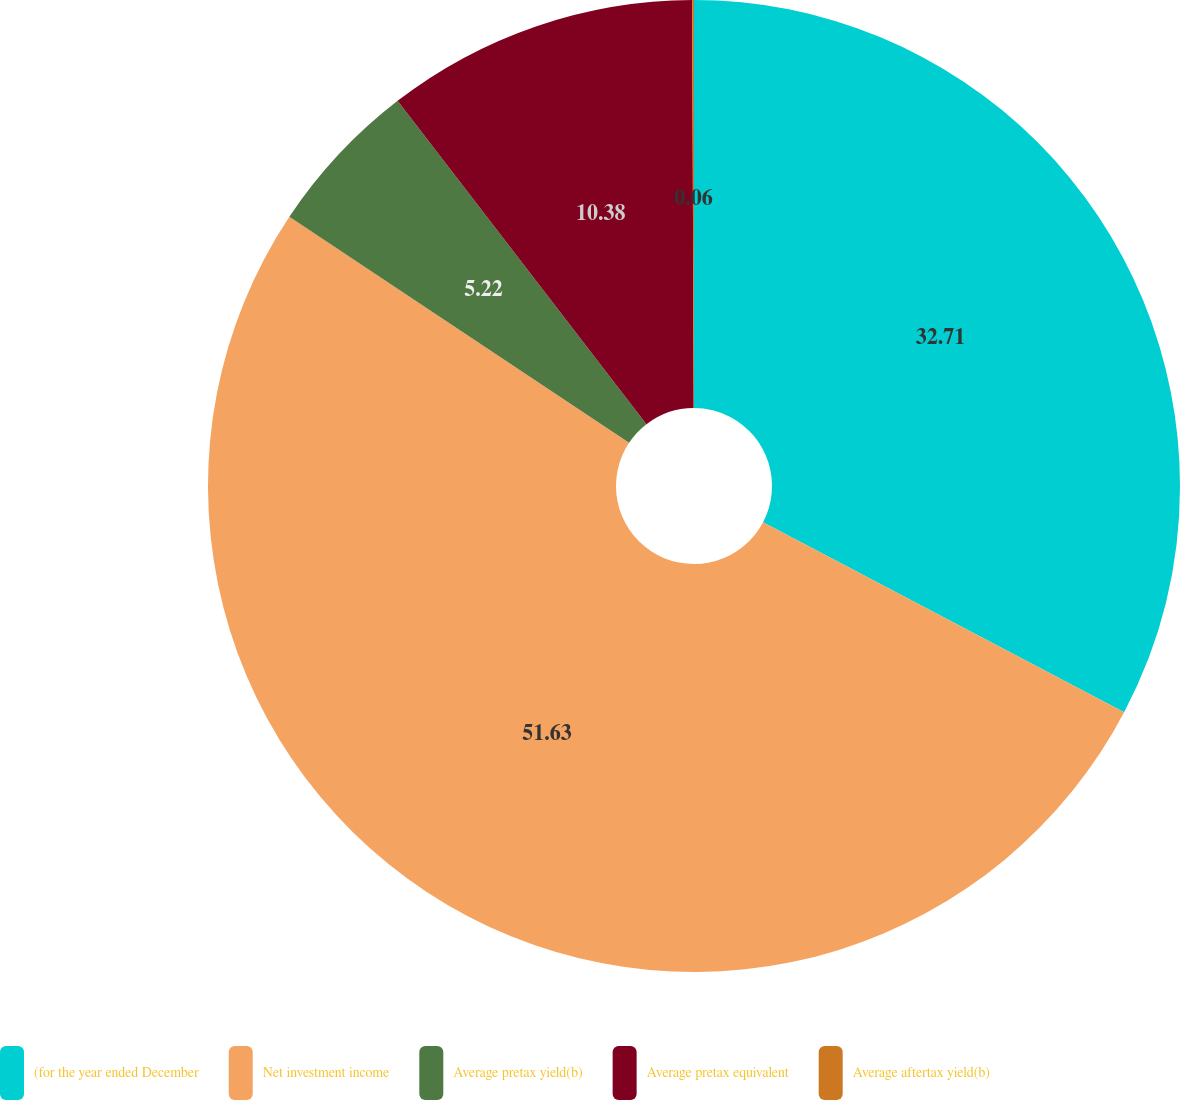Convert chart. <chart><loc_0><loc_0><loc_500><loc_500><pie_chart><fcel>(for the year ended December<fcel>Net investment income<fcel>Average pretax yield(b)<fcel>Average pretax equivalent<fcel>Average aftertax yield(b)<nl><fcel>32.71%<fcel>51.64%<fcel>5.22%<fcel>10.38%<fcel>0.06%<nl></chart> 